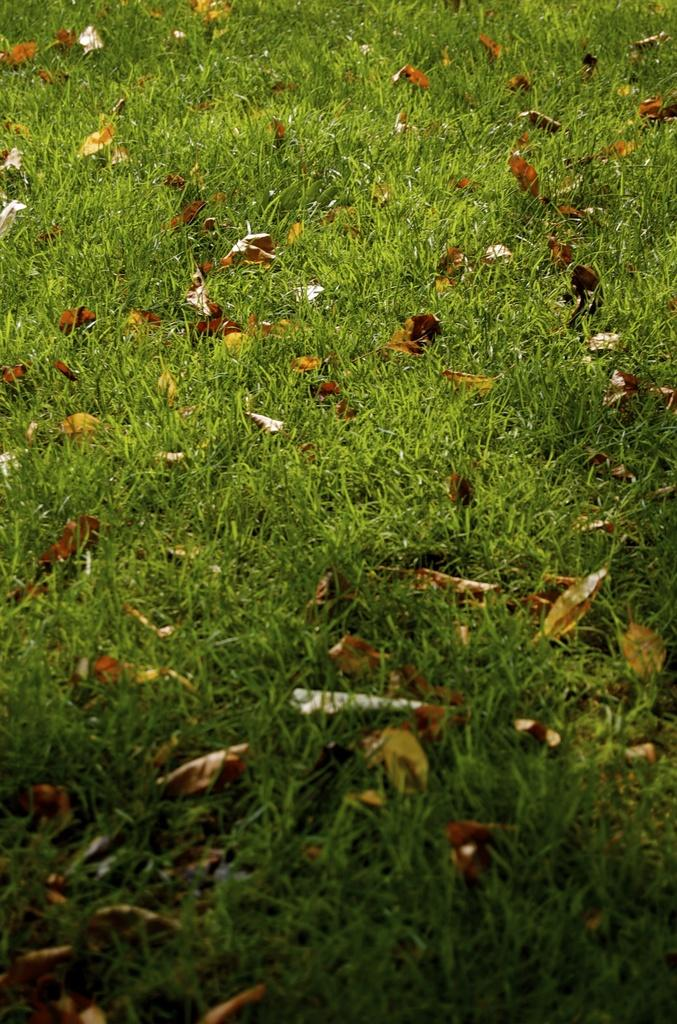What type of vegetation can be seen on the ground in the image? There are dried leaves and grass on the ground in the image. Can you describe the texture of the ground in the image? The ground appears to be covered with dried leaves and grass, which suggests a natural, textured surface. What type of mint is growing in the image? There is no mint present in the image; it only features dried leaves and grass on the ground. 